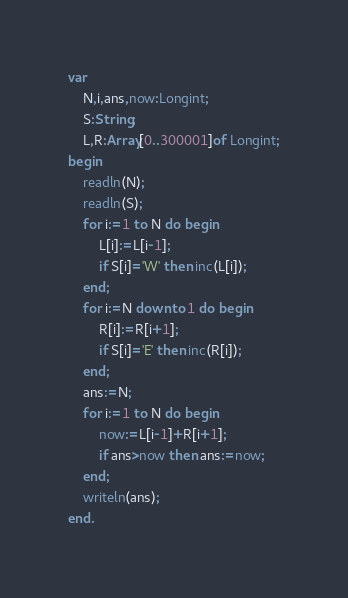<code> <loc_0><loc_0><loc_500><loc_500><_Pascal_>var
	N,i,ans,now:Longint;
	S:String;
	L,R:Array[0..300001]of Longint;
begin
	readln(N);
	readln(S);
	for i:=1 to N do begin
		L[i]:=L[i-1];
		if S[i]='W' then inc(L[i]);
	end;
	for i:=N downto 1 do begin
		R[i]:=R[i+1];
		if S[i]='E' then inc(R[i]);
	end;
	ans:=N;
	for i:=1 to N do begin
		now:=L[i-1]+R[i+1];
		if ans>now then ans:=now;
	end;
	writeln(ans);
end.
</code> 